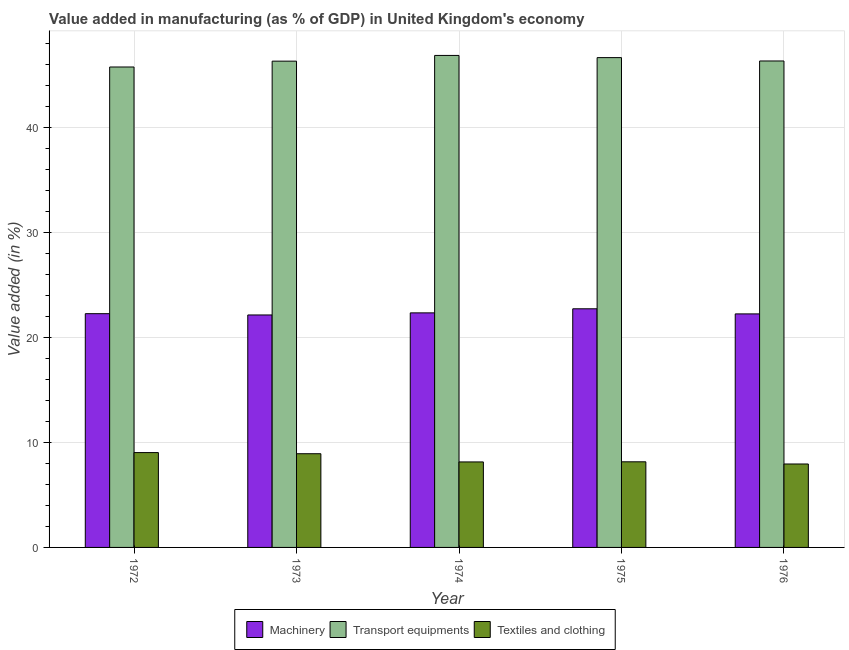How many different coloured bars are there?
Provide a short and direct response. 3. What is the label of the 5th group of bars from the left?
Provide a short and direct response. 1976. What is the value added in manufacturing machinery in 1976?
Your answer should be compact. 22.23. Across all years, what is the maximum value added in manufacturing machinery?
Provide a succinct answer. 22.72. Across all years, what is the minimum value added in manufacturing machinery?
Ensure brevity in your answer.  22.13. In which year was the value added in manufacturing machinery maximum?
Your response must be concise. 1975. In which year was the value added in manufacturing textile and clothing minimum?
Provide a short and direct response. 1976. What is the total value added in manufacturing transport equipments in the graph?
Offer a terse response. 231.81. What is the difference between the value added in manufacturing transport equipments in 1974 and that in 1976?
Make the answer very short. 0.53. What is the difference between the value added in manufacturing transport equipments in 1972 and the value added in manufacturing machinery in 1974?
Ensure brevity in your answer.  -1.1. What is the average value added in manufacturing machinery per year?
Offer a very short reply. 22.33. In the year 1976, what is the difference between the value added in manufacturing textile and clothing and value added in manufacturing transport equipments?
Make the answer very short. 0. In how many years, is the value added in manufacturing transport equipments greater than 28 %?
Provide a short and direct response. 5. What is the ratio of the value added in manufacturing transport equipments in 1972 to that in 1975?
Make the answer very short. 0.98. What is the difference between the highest and the second highest value added in manufacturing machinery?
Offer a very short reply. 0.39. What is the difference between the highest and the lowest value added in manufacturing textile and clothing?
Your answer should be very brief. 1.09. Is the sum of the value added in manufacturing textile and clothing in 1972 and 1975 greater than the maximum value added in manufacturing transport equipments across all years?
Offer a very short reply. Yes. What does the 3rd bar from the left in 1974 represents?
Ensure brevity in your answer.  Textiles and clothing. What does the 1st bar from the right in 1976 represents?
Keep it short and to the point. Textiles and clothing. Is it the case that in every year, the sum of the value added in manufacturing machinery and value added in manufacturing transport equipments is greater than the value added in manufacturing textile and clothing?
Ensure brevity in your answer.  Yes. How many bars are there?
Give a very brief answer. 15. Are all the bars in the graph horizontal?
Keep it short and to the point. No. How many years are there in the graph?
Your answer should be very brief. 5. Are the values on the major ticks of Y-axis written in scientific E-notation?
Your answer should be compact. No. Does the graph contain grids?
Make the answer very short. Yes. What is the title of the graph?
Your answer should be compact. Value added in manufacturing (as % of GDP) in United Kingdom's economy. What is the label or title of the X-axis?
Offer a terse response. Year. What is the label or title of the Y-axis?
Provide a succinct answer. Value added (in %). What is the Value added (in %) of Machinery in 1972?
Give a very brief answer. 22.25. What is the Value added (in %) of Transport equipments in 1972?
Your answer should be compact. 45.74. What is the Value added (in %) in Textiles and clothing in 1972?
Provide a short and direct response. 9.03. What is the Value added (in %) in Machinery in 1973?
Your response must be concise. 22.13. What is the Value added (in %) in Transport equipments in 1973?
Offer a very short reply. 46.29. What is the Value added (in %) in Textiles and clothing in 1973?
Offer a very short reply. 8.92. What is the Value added (in %) of Machinery in 1974?
Your response must be concise. 22.33. What is the Value added (in %) of Transport equipments in 1974?
Your answer should be very brief. 46.84. What is the Value added (in %) of Textiles and clothing in 1974?
Your response must be concise. 8.14. What is the Value added (in %) in Machinery in 1975?
Give a very brief answer. 22.72. What is the Value added (in %) in Transport equipments in 1975?
Give a very brief answer. 46.63. What is the Value added (in %) in Textiles and clothing in 1975?
Give a very brief answer. 8.15. What is the Value added (in %) of Machinery in 1976?
Offer a very short reply. 22.23. What is the Value added (in %) in Transport equipments in 1976?
Give a very brief answer. 46.31. What is the Value added (in %) in Textiles and clothing in 1976?
Your answer should be very brief. 7.94. Across all years, what is the maximum Value added (in %) in Machinery?
Offer a very short reply. 22.72. Across all years, what is the maximum Value added (in %) in Transport equipments?
Your response must be concise. 46.84. Across all years, what is the maximum Value added (in %) of Textiles and clothing?
Keep it short and to the point. 9.03. Across all years, what is the minimum Value added (in %) in Machinery?
Offer a terse response. 22.13. Across all years, what is the minimum Value added (in %) of Transport equipments?
Make the answer very short. 45.74. Across all years, what is the minimum Value added (in %) of Textiles and clothing?
Your answer should be very brief. 7.94. What is the total Value added (in %) in Machinery in the graph?
Offer a terse response. 111.66. What is the total Value added (in %) of Transport equipments in the graph?
Offer a very short reply. 231.81. What is the total Value added (in %) in Textiles and clothing in the graph?
Make the answer very short. 42.18. What is the difference between the Value added (in %) in Machinery in 1972 and that in 1973?
Ensure brevity in your answer.  0.12. What is the difference between the Value added (in %) of Transport equipments in 1972 and that in 1973?
Your response must be concise. -0.56. What is the difference between the Value added (in %) in Textiles and clothing in 1972 and that in 1973?
Provide a short and direct response. 0.11. What is the difference between the Value added (in %) in Machinery in 1972 and that in 1974?
Offer a very short reply. -0.08. What is the difference between the Value added (in %) in Transport equipments in 1972 and that in 1974?
Make the answer very short. -1.1. What is the difference between the Value added (in %) in Textiles and clothing in 1972 and that in 1974?
Your answer should be very brief. 0.89. What is the difference between the Value added (in %) of Machinery in 1972 and that in 1975?
Ensure brevity in your answer.  -0.47. What is the difference between the Value added (in %) in Transport equipments in 1972 and that in 1975?
Your response must be concise. -0.89. What is the difference between the Value added (in %) of Textiles and clothing in 1972 and that in 1975?
Your answer should be compact. 0.88. What is the difference between the Value added (in %) of Machinery in 1972 and that in 1976?
Keep it short and to the point. 0.02. What is the difference between the Value added (in %) in Transport equipments in 1972 and that in 1976?
Offer a terse response. -0.57. What is the difference between the Value added (in %) in Textiles and clothing in 1972 and that in 1976?
Your response must be concise. 1.09. What is the difference between the Value added (in %) of Machinery in 1973 and that in 1974?
Provide a short and direct response. -0.2. What is the difference between the Value added (in %) in Transport equipments in 1973 and that in 1974?
Ensure brevity in your answer.  -0.55. What is the difference between the Value added (in %) in Textiles and clothing in 1973 and that in 1974?
Keep it short and to the point. 0.78. What is the difference between the Value added (in %) of Machinery in 1973 and that in 1975?
Give a very brief answer. -0.59. What is the difference between the Value added (in %) of Transport equipments in 1973 and that in 1975?
Offer a very short reply. -0.34. What is the difference between the Value added (in %) in Textiles and clothing in 1973 and that in 1975?
Make the answer very short. 0.77. What is the difference between the Value added (in %) of Machinery in 1973 and that in 1976?
Offer a very short reply. -0.1. What is the difference between the Value added (in %) in Transport equipments in 1973 and that in 1976?
Make the answer very short. -0.02. What is the difference between the Value added (in %) of Textiles and clothing in 1973 and that in 1976?
Offer a very short reply. 0.98. What is the difference between the Value added (in %) of Machinery in 1974 and that in 1975?
Offer a very short reply. -0.39. What is the difference between the Value added (in %) of Transport equipments in 1974 and that in 1975?
Your response must be concise. 0.21. What is the difference between the Value added (in %) of Textiles and clothing in 1974 and that in 1975?
Provide a short and direct response. -0.01. What is the difference between the Value added (in %) of Machinery in 1974 and that in 1976?
Your response must be concise. 0.1. What is the difference between the Value added (in %) of Transport equipments in 1974 and that in 1976?
Keep it short and to the point. 0.53. What is the difference between the Value added (in %) of Textiles and clothing in 1974 and that in 1976?
Give a very brief answer. 0.2. What is the difference between the Value added (in %) in Machinery in 1975 and that in 1976?
Make the answer very short. 0.49. What is the difference between the Value added (in %) of Transport equipments in 1975 and that in 1976?
Your answer should be compact. 0.32. What is the difference between the Value added (in %) in Textiles and clothing in 1975 and that in 1976?
Ensure brevity in your answer.  0.21. What is the difference between the Value added (in %) in Machinery in 1972 and the Value added (in %) in Transport equipments in 1973?
Your answer should be compact. -24.04. What is the difference between the Value added (in %) of Machinery in 1972 and the Value added (in %) of Textiles and clothing in 1973?
Your answer should be very brief. 13.33. What is the difference between the Value added (in %) of Transport equipments in 1972 and the Value added (in %) of Textiles and clothing in 1973?
Provide a short and direct response. 36.82. What is the difference between the Value added (in %) in Machinery in 1972 and the Value added (in %) in Transport equipments in 1974?
Provide a short and direct response. -24.59. What is the difference between the Value added (in %) in Machinery in 1972 and the Value added (in %) in Textiles and clothing in 1974?
Provide a succinct answer. 14.11. What is the difference between the Value added (in %) in Transport equipments in 1972 and the Value added (in %) in Textiles and clothing in 1974?
Offer a terse response. 37.6. What is the difference between the Value added (in %) in Machinery in 1972 and the Value added (in %) in Transport equipments in 1975?
Your answer should be very brief. -24.38. What is the difference between the Value added (in %) in Machinery in 1972 and the Value added (in %) in Textiles and clothing in 1975?
Your answer should be compact. 14.1. What is the difference between the Value added (in %) of Transport equipments in 1972 and the Value added (in %) of Textiles and clothing in 1975?
Provide a short and direct response. 37.59. What is the difference between the Value added (in %) in Machinery in 1972 and the Value added (in %) in Transport equipments in 1976?
Your answer should be compact. -24.06. What is the difference between the Value added (in %) in Machinery in 1972 and the Value added (in %) in Textiles and clothing in 1976?
Make the answer very short. 14.31. What is the difference between the Value added (in %) of Transport equipments in 1972 and the Value added (in %) of Textiles and clothing in 1976?
Offer a very short reply. 37.79. What is the difference between the Value added (in %) in Machinery in 1973 and the Value added (in %) in Transport equipments in 1974?
Offer a very short reply. -24.71. What is the difference between the Value added (in %) of Machinery in 1973 and the Value added (in %) of Textiles and clothing in 1974?
Give a very brief answer. 13.99. What is the difference between the Value added (in %) in Transport equipments in 1973 and the Value added (in %) in Textiles and clothing in 1974?
Make the answer very short. 38.15. What is the difference between the Value added (in %) of Machinery in 1973 and the Value added (in %) of Transport equipments in 1975?
Give a very brief answer. -24.5. What is the difference between the Value added (in %) in Machinery in 1973 and the Value added (in %) in Textiles and clothing in 1975?
Ensure brevity in your answer.  13.98. What is the difference between the Value added (in %) in Transport equipments in 1973 and the Value added (in %) in Textiles and clothing in 1975?
Offer a terse response. 38.14. What is the difference between the Value added (in %) of Machinery in 1973 and the Value added (in %) of Transport equipments in 1976?
Offer a very short reply. -24.18. What is the difference between the Value added (in %) in Machinery in 1973 and the Value added (in %) in Textiles and clothing in 1976?
Give a very brief answer. 14.19. What is the difference between the Value added (in %) in Transport equipments in 1973 and the Value added (in %) in Textiles and clothing in 1976?
Your response must be concise. 38.35. What is the difference between the Value added (in %) in Machinery in 1974 and the Value added (in %) in Transport equipments in 1975?
Offer a terse response. -24.3. What is the difference between the Value added (in %) of Machinery in 1974 and the Value added (in %) of Textiles and clothing in 1975?
Provide a short and direct response. 14.18. What is the difference between the Value added (in %) in Transport equipments in 1974 and the Value added (in %) in Textiles and clothing in 1975?
Provide a short and direct response. 38.69. What is the difference between the Value added (in %) in Machinery in 1974 and the Value added (in %) in Transport equipments in 1976?
Make the answer very short. -23.98. What is the difference between the Value added (in %) in Machinery in 1974 and the Value added (in %) in Textiles and clothing in 1976?
Your answer should be very brief. 14.39. What is the difference between the Value added (in %) of Transport equipments in 1974 and the Value added (in %) of Textiles and clothing in 1976?
Provide a succinct answer. 38.89. What is the difference between the Value added (in %) of Machinery in 1975 and the Value added (in %) of Transport equipments in 1976?
Keep it short and to the point. -23.59. What is the difference between the Value added (in %) in Machinery in 1975 and the Value added (in %) in Textiles and clothing in 1976?
Offer a very short reply. 14.78. What is the difference between the Value added (in %) in Transport equipments in 1975 and the Value added (in %) in Textiles and clothing in 1976?
Offer a terse response. 38.69. What is the average Value added (in %) of Machinery per year?
Ensure brevity in your answer.  22.33. What is the average Value added (in %) of Transport equipments per year?
Offer a very short reply. 46.36. What is the average Value added (in %) of Textiles and clothing per year?
Ensure brevity in your answer.  8.44. In the year 1972, what is the difference between the Value added (in %) of Machinery and Value added (in %) of Transport equipments?
Make the answer very short. -23.48. In the year 1972, what is the difference between the Value added (in %) of Machinery and Value added (in %) of Textiles and clothing?
Ensure brevity in your answer.  13.22. In the year 1972, what is the difference between the Value added (in %) in Transport equipments and Value added (in %) in Textiles and clothing?
Your answer should be compact. 36.71. In the year 1973, what is the difference between the Value added (in %) in Machinery and Value added (in %) in Transport equipments?
Give a very brief answer. -24.16. In the year 1973, what is the difference between the Value added (in %) in Machinery and Value added (in %) in Textiles and clothing?
Your answer should be very brief. 13.21. In the year 1973, what is the difference between the Value added (in %) of Transport equipments and Value added (in %) of Textiles and clothing?
Your answer should be compact. 37.37. In the year 1974, what is the difference between the Value added (in %) of Machinery and Value added (in %) of Transport equipments?
Offer a very short reply. -24.51. In the year 1974, what is the difference between the Value added (in %) of Machinery and Value added (in %) of Textiles and clothing?
Offer a terse response. 14.19. In the year 1974, what is the difference between the Value added (in %) in Transport equipments and Value added (in %) in Textiles and clothing?
Your answer should be very brief. 38.7. In the year 1975, what is the difference between the Value added (in %) of Machinery and Value added (in %) of Transport equipments?
Give a very brief answer. -23.91. In the year 1975, what is the difference between the Value added (in %) of Machinery and Value added (in %) of Textiles and clothing?
Your answer should be very brief. 14.57. In the year 1975, what is the difference between the Value added (in %) of Transport equipments and Value added (in %) of Textiles and clothing?
Give a very brief answer. 38.48. In the year 1976, what is the difference between the Value added (in %) of Machinery and Value added (in %) of Transport equipments?
Ensure brevity in your answer.  -24.08. In the year 1976, what is the difference between the Value added (in %) in Machinery and Value added (in %) in Textiles and clothing?
Provide a succinct answer. 14.29. In the year 1976, what is the difference between the Value added (in %) in Transport equipments and Value added (in %) in Textiles and clothing?
Ensure brevity in your answer.  38.37. What is the ratio of the Value added (in %) in Machinery in 1972 to that in 1973?
Your answer should be very brief. 1.01. What is the ratio of the Value added (in %) of Textiles and clothing in 1972 to that in 1973?
Offer a very short reply. 1.01. What is the ratio of the Value added (in %) of Machinery in 1972 to that in 1974?
Provide a succinct answer. 1. What is the ratio of the Value added (in %) of Transport equipments in 1972 to that in 1974?
Keep it short and to the point. 0.98. What is the ratio of the Value added (in %) in Textiles and clothing in 1972 to that in 1974?
Give a very brief answer. 1.11. What is the ratio of the Value added (in %) in Machinery in 1972 to that in 1975?
Your answer should be very brief. 0.98. What is the ratio of the Value added (in %) in Transport equipments in 1972 to that in 1975?
Your answer should be compact. 0.98. What is the ratio of the Value added (in %) in Textiles and clothing in 1972 to that in 1975?
Make the answer very short. 1.11. What is the ratio of the Value added (in %) in Machinery in 1972 to that in 1976?
Your response must be concise. 1. What is the ratio of the Value added (in %) of Transport equipments in 1972 to that in 1976?
Your answer should be compact. 0.99. What is the ratio of the Value added (in %) of Textiles and clothing in 1972 to that in 1976?
Provide a succinct answer. 1.14. What is the ratio of the Value added (in %) in Machinery in 1973 to that in 1974?
Your answer should be very brief. 0.99. What is the ratio of the Value added (in %) of Transport equipments in 1973 to that in 1974?
Your response must be concise. 0.99. What is the ratio of the Value added (in %) of Textiles and clothing in 1973 to that in 1974?
Give a very brief answer. 1.1. What is the ratio of the Value added (in %) of Machinery in 1973 to that in 1975?
Your answer should be compact. 0.97. What is the ratio of the Value added (in %) of Transport equipments in 1973 to that in 1975?
Offer a terse response. 0.99. What is the ratio of the Value added (in %) of Textiles and clothing in 1973 to that in 1975?
Make the answer very short. 1.09. What is the ratio of the Value added (in %) in Machinery in 1973 to that in 1976?
Keep it short and to the point. 1. What is the ratio of the Value added (in %) of Textiles and clothing in 1973 to that in 1976?
Make the answer very short. 1.12. What is the ratio of the Value added (in %) of Machinery in 1974 to that in 1975?
Keep it short and to the point. 0.98. What is the ratio of the Value added (in %) in Transport equipments in 1974 to that in 1975?
Your answer should be compact. 1. What is the ratio of the Value added (in %) of Textiles and clothing in 1974 to that in 1975?
Offer a very short reply. 1. What is the ratio of the Value added (in %) in Machinery in 1974 to that in 1976?
Give a very brief answer. 1. What is the ratio of the Value added (in %) in Transport equipments in 1974 to that in 1976?
Offer a terse response. 1.01. What is the ratio of the Value added (in %) of Textiles and clothing in 1974 to that in 1976?
Your answer should be compact. 1.02. What is the ratio of the Value added (in %) of Machinery in 1975 to that in 1976?
Make the answer very short. 1.02. What is the ratio of the Value added (in %) of Textiles and clothing in 1975 to that in 1976?
Offer a terse response. 1.03. What is the difference between the highest and the second highest Value added (in %) in Machinery?
Provide a succinct answer. 0.39. What is the difference between the highest and the second highest Value added (in %) of Transport equipments?
Make the answer very short. 0.21. What is the difference between the highest and the second highest Value added (in %) of Textiles and clothing?
Keep it short and to the point. 0.11. What is the difference between the highest and the lowest Value added (in %) in Machinery?
Make the answer very short. 0.59. What is the difference between the highest and the lowest Value added (in %) in Transport equipments?
Make the answer very short. 1.1. What is the difference between the highest and the lowest Value added (in %) of Textiles and clothing?
Ensure brevity in your answer.  1.09. 